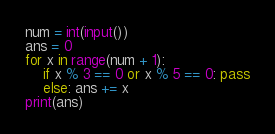Convert code to text. <code><loc_0><loc_0><loc_500><loc_500><_Python_>num = int(input())
ans = 0
for x in range(num + 1):
    if x % 3 == 0 or x % 5 == 0: pass
    else: ans += x
print(ans)</code> 